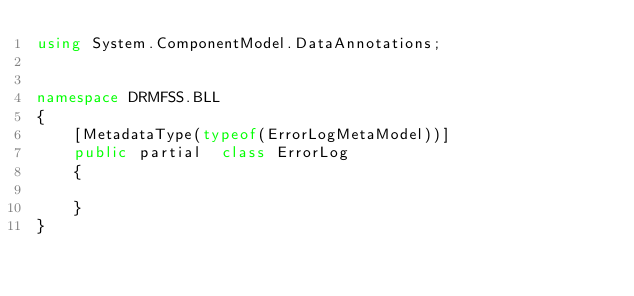<code> <loc_0><loc_0><loc_500><loc_500><_C#_>using System.ComponentModel.DataAnnotations;


namespace DRMFSS.BLL
{
    [MetadataType(typeof(ErrorLogMetaModel))]
    public partial  class ErrorLog
    {
            
    }
}
</code> 